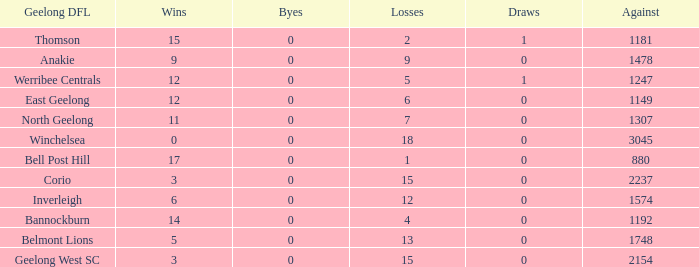What is the highest number of byes where the losses were 9 and the draws were less than 0? None. 